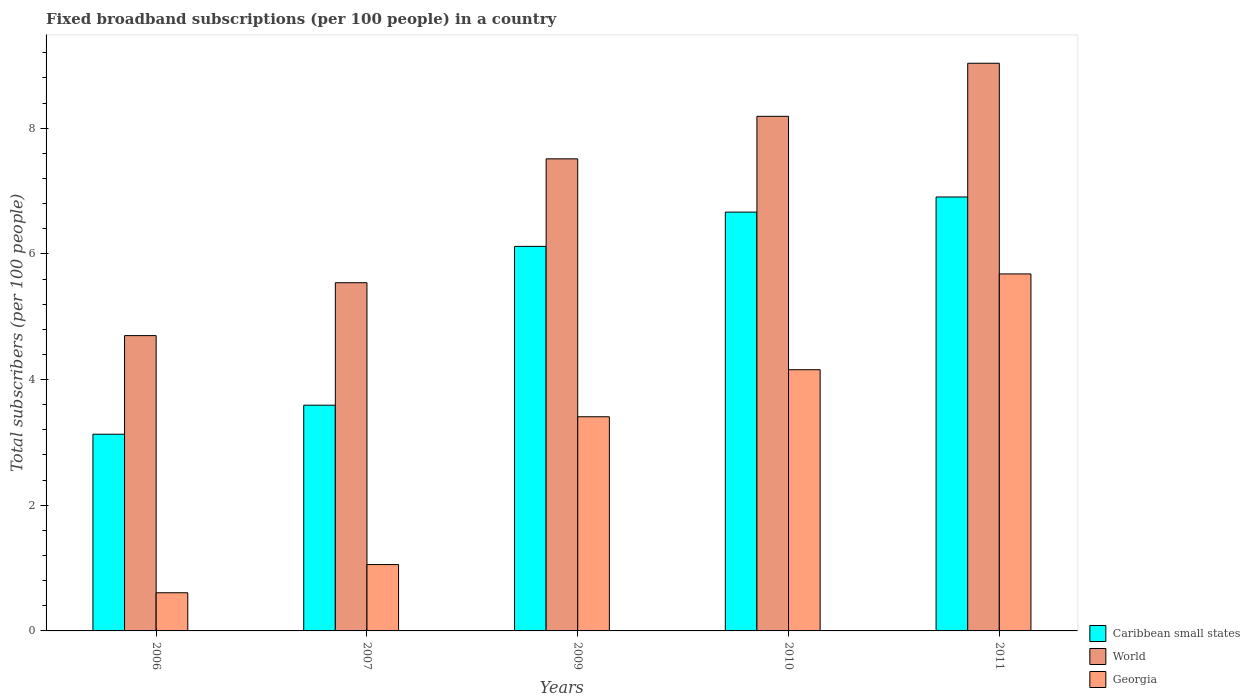How many groups of bars are there?
Your answer should be very brief. 5. Are the number of bars on each tick of the X-axis equal?
Offer a terse response. Yes. How many bars are there on the 3rd tick from the left?
Ensure brevity in your answer.  3. How many bars are there on the 3rd tick from the right?
Ensure brevity in your answer.  3. What is the number of broadband subscriptions in Caribbean small states in 2006?
Provide a succinct answer. 3.13. Across all years, what is the maximum number of broadband subscriptions in World?
Offer a terse response. 9.03. Across all years, what is the minimum number of broadband subscriptions in Caribbean small states?
Offer a terse response. 3.13. What is the total number of broadband subscriptions in World in the graph?
Ensure brevity in your answer.  34.98. What is the difference between the number of broadband subscriptions in World in 2006 and that in 2007?
Offer a very short reply. -0.84. What is the difference between the number of broadband subscriptions in World in 2010 and the number of broadband subscriptions in Georgia in 2009?
Your response must be concise. 4.78. What is the average number of broadband subscriptions in World per year?
Provide a short and direct response. 7. In the year 2009, what is the difference between the number of broadband subscriptions in Georgia and number of broadband subscriptions in Caribbean small states?
Offer a terse response. -2.71. In how many years, is the number of broadband subscriptions in World greater than 2.8?
Offer a very short reply. 5. What is the ratio of the number of broadband subscriptions in Caribbean small states in 2010 to that in 2011?
Provide a succinct answer. 0.97. Is the difference between the number of broadband subscriptions in Georgia in 2007 and 2010 greater than the difference between the number of broadband subscriptions in Caribbean small states in 2007 and 2010?
Provide a short and direct response. No. What is the difference between the highest and the second highest number of broadband subscriptions in Georgia?
Your answer should be compact. 1.52. What is the difference between the highest and the lowest number of broadband subscriptions in Georgia?
Provide a succinct answer. 5.07. What does the 1st bar from the left in 2006 represents?
Give a very brief answer. Caribbean small states. What does the 3rd bar from the right in 2009 represents?
Your answer should be compact. Caribbean small states. How many bars are there?
Your answer should be very brief. 15. Are all the bars in the graph horizontal?
Ensure brevity in your answer.  No. How many years are there in the graph?
Keep it short and to the point. 5. What is the difference between two consecutive major ticks on the Y-axis?
Your response must be concise. 2. Are the values on the major ticks of Y-axis written in scientific E-notation?
Your response must be concise. No. Where does the legend appear in the graph?
Ensure brevity in your answer.  Bottom right. How many legend labels are there?
Your answer should be very brief. 3. How are the legend labels stacked?
Your answer should be compact. Vertical. What is the title of the graph?
Your answer should be compact. Fixed broadband subscriptions (per 100 people) in a country. Does "Kazakhstan" appear as one of the legend labels in the graph?
Your response must be concise. No. What is the label or title of the Y-axis?
Your answer should be compact. Total subscribers (per 100 people). What is the Total subscribers (per 100 people) in Caribbean small states in 2006?
Make the answer very short. 3.13. What is the Total subscribers (per 100 people) in World in 2006?
Your answer should be very brief. 4.7. What is the Total subscribers (per 100 people) of Georgia in 2006?
Give a very brief answer. 0.61. What is the Total subscribers (per 100 people) in Caribbean small states in 2007?
Provide a short and direct response. 3.59. What is the Total subscribers (per 100 people) in World in 2007?
Your answer should be compact. 5.54. What is the Total subscribers (per 100 people) of Georgia in 2007?
Offer a very short reply. 1.06. What is the Total subscribers (per 100 people) in Caribbean small states in 2009?
Your response must be concise. 6.12. What is the Total subscribers (per 100 people) in World in 2009?
Ensure brevity in your answer.  7.51. What is the Total subscribers (per 100 people) in Georgia in 2009?
Make the answer very short. 3.41. What is the Total subscribers (per 100 people) of Caribbean small states in 2010?
Offer a very short reply. 6.66. What is the Total subscribers (per 100 people) of World in 2010?
Your response must be concise. 8.19. What is the Total subscribers (per 100 people) of Georgia in 2010?
Ensure brevity in your answer.  4.16. What is the Total subscribers (per 100 people) of Caribbean small states in 2011?
Your answer should be compact. 6.91. What is the Total subscribers (per 100 people) of World in 2011?
Provide a short and direct response. 9.03. What is the Total subscribers (per 100 people) of Georgia in 2011?
Your response must be concise. 5.68. Across all years, what is the maximum Total subscribers (per 100 people) of Caribbean small states?
Provide a short and direct response. 6.91. Across all years, what is the maximum Total subscribers (per 100 people) in World?
Keep it short and to the point. 9.03. Across all years, what is the maximum Total subscribers (per 100 people) in Georgia?
Your answer should be very brief. 5.68. Across all years, what is the minimum Total subscribers (per 100 people) in Caribbean small states?
Provide a short and direct response. 3.13. Across all years, what is the minimum Total subscribers (per 100 people) of World?
Keep it short and to the point. 4.7. Across all years, what is the minimum Total subscribers (per 100 people) in Georgia?
Offer a very short reply. 0.61. What is the total Total subscribers (per 100 people) of Caribbean small states in the graph?
Your answer should be compact. 26.41. What is the total Total subscribers (per 100 people) of World in the graph?
Your answer should be very brief. 34.98. What is the total Total subscribers (per 100 people) in Georgia in the graph?
Offer a very short reply. 14.91. What is the difference between the Total subscribers (per 100 people) in Caribbean small states in 2006 and that in 2007?
Your answer should be very brief. -0.46. What is the difference between the Total subscribers (per 100 people) in World in 2006 and that in 2007?
Provide a short and direct response. -0.84. What is the difference between the Total subscribers (per 100 people) in Georgia in 2006 and that in 2007?
Your answer should be compact. -0.45. What is the difference between the Total subscribers (per 100 people) of Caribbean small states in 2006 and that in 2009?
Provide a succinct answer. -2.99. What is the difference between the Total subscribers (per 100 people) in World in 2006 and that in 2009?
Provide a short and direct response. -2.81. What is the difference between the Total subscribers (per 100 people) in Georgia in 2006 and that in 2009?
Your answer should be very brief. -2.8. What is the difference between the Total subscribers (per 100 people) of Caribbean small states in 2006 and that in 2010?
Provide a short and direct response. -3.53. What is the difference between the Total subscribers (per 100 people) in World in 2006 and that in 2010?
Your answer should be very brief. -3.49. What is the difference between the Total subscribers (per 100 people) in Georgia in 2006 and that in 2010?
Ensure brevity in your answer.  -3.55. What is the difference between the Total subscribers (per 100 people) of Caribbean small states in 2006 and that in 2011?
Make the answer very short. -3.78. What is the difference between the Total subscribers (per 100 people) of World in 2006 and that in 2011?
Your response must be concise. -4.33. What is the difference between the Total subscribers (per 100 people) in Georgia in 2006 and that in 2011?
Provide a succinct answer. -5.07. What is the difference between the Total subscribers (per 100 people) of Caribbean small states in 2007 and that in 2009?
Make the answer very short. -2.53. What is the difference between the Total subscribers (per 100 people) in World in 2007 and that in 2009?
Keep it short and to the point. -1.97. What is the difference between the Total subscribers (per 100 people) in Georgia in 2007 and that in 2009?
Your answer should be compact. -2.35. What is the difference between the Total subscribers (per 100 people) of Caribbean small states in 2007 and that in 2010?
Offer a terse response. -3.07. What is the difference between the Total subscribers (per 100 people) in World in 2007 and that in 2010?
Provide a succinct answer. -2.65. What is the difference between the Total subscribers (per 100 people) of Georgia in 2007 and that in 2010?
Keep it short and to the point. -3.1. What is the difference between the Total subscribers (per 100 people) of Caribbean small states in 2007 and that in 2011?
Your answer should be compact. -3.31. What is the difference between the Total subscribers (per 100 people) of World in 2007 and that in 2011?
Provide a succinct answer. -3.49. What is the difference between the Total subscribers (per 100 people) in Georgia in 2007 and that in 2011?
Your response must be concise. -4.63. What is the difference between the Total subscribers (per 100 people) in Caribbean small states in 2009 and that in 2010?
Your response must be concise. -0.55. What is the difference between the Total subscribers (per 100 people) of World in 2009 and that in 2010?
Provide a short and direct response. -0.68. What is the difference between the Total subscribers (per 100 people) of Georgia in 2009 and that in 2010?
Provide a short and direct response. -0.75. What is the difference between the Total subscribers (per 100 people) in Caribbean small states in 2009 and that in 2011?
Keep it short and to the point. -0.79. What is the difference between the Total subscribers (per 100 people) in World in 2009 and that in 2011?
Keep it short and to the point. -1.52. What is the difference between the Total subscribers (per 100 people) in Georgia in 2009 and that in 2011?
Offer a terse response. -2.27. What is the difference between the Total subscribers (per 100 people) of Caribbean small states in 2010 and that in 2011?
Provide a short and direct response. -0.24. What is the difference between the Total subscribers (per 100 people) in World in 2010 and that in 2011?
Give a very brief answer. -0.84. What is the difference between the Total subscribers (per 100 people) of Georgia in 2010 and that in 2011?
Offer a terse response. -1.52. What is the difference between the Total subscribers (per 100 people) in Caribbean small states in 2006 and the Total subscribers (per 100 people) in World in 2007?
Offer a terse response. -2.41. What is the difference between the Total subscribers (per 100 people) in Caribbean small states in 2006 and the Total subscribers (per 100 people) in Georgia in 2007?
Offer a terse response. 2.07. What is the difference between the Total subscribers (per 100 people) of World in 2006 and the Total subscribers (per 100 people) of Georgia in 2007?
Your answer should be compact. 3.64. What is the difference between the Total subscribers (per 100 people) in Caribbean small states in 2006 and the Total subscribers (per 100 people) in World in 2009?
Provide a succinct answer. -4.38. What is the difference between the Total subscribers (per 100 people) of Caribbean small states in 2006 and the Total subscribers (per 100 people) of Georgia in 2009?
Offer a very short reply. -0.28. What is the difference between the Total subscribers (per 100 people) of World in 2006 and the Total subscribers (per 100 people) of Georgia in 2009?
Provide a short and direct response. 1.29. What is the difference between the Total subscribers (per 100 people) in Caribbean small states in 2006 and the Total subscribers (per 100 people) in World in 2010?
Your response must be concise. -5.06. What is the difference between the Total subscribers (per 100 people) of Caribbean small states in 2006 and the Total subscribers (per 100 people) of Georgia in 2010?
Your answer should be very brief. -1.03. What is the difference between the Total subscribers (per 100 people) of World in 2006 and the Total subscribers (per 100 people) of Georgia in 2010?
Ensure brevity in your answer.  0.54. What is the difference between the Total subscribers (per 100 people) of Caribbean small states in 2006 and the Total subscribers (per 100 people) of World in 2011?
Make the answer very short. -5.9. What is the difference between the Total subscribers (per 100 people) of Caribbean small states in 2006 and the Total subscribers (per 100 people) of Georgia in 2011?
Your response must be concise. -2.55. What is the difference between the Total subscribers (per 100 people) of World in 2006 and the Total subscribers (per 100 people) of Georgia in 2011?
Give a very brief answer. -0.98. What is the difference between the Total subscribers (per 100 people) in Caribbean small states in 2007 and the Total subscribers (per 100 people) in World in 2009?
Ensure brevity in your answer.  -3.92. What is the difference between the Total subscribers (per 100 people) in Caribbean small states in 2007 and the Total subscribers (per 100 people) in Georgia in 2009?
Your response must be concise. 0.18. What is the difference between the Total subscribers (per 100 people) of World in 2007 and the Total subscribers (per 100 people) of Georgia in 2009?
Give a very brief answer. 2.13. What is the difference between the Total subscribers (per 100 people) of Caribbean small states in 2007 and the Total subscribers (per 100 people) of World in 2010?
Provide a short and direct response. -4.6. What is the difference between the Total subscribers (per 100 people) in Caribbean small states in 2007 and the Total subscribers (per 100 people) in Georgia in 2010?
Make the answer very short. -0.56. What is the difference between the Total subscribers (per 100 people) in World in 2007 and the Total subscribers (per 100 people) in Georgia in 2010?
Offer a very short reply. 1.38. What is the difference between the Total subscribers (per 100 people) of Caribbean small states in 2007 and the Total subscribers (per 100 people) of World in 2011?
Keep it short and to the point. -5.44. What is the difference between the Total subscribers (per 100 people) of Caribbean small states in 2007 and the Total subscribers (per 100 people) of Georgia in 2011?
Your answer should be compact. -2.09. What is the difference between the Total subscribers (per 100 people) of World in 2007 and the Total subscribers (per 100 people) of Georgia in 2011?
Offer a terse response. -0.14. What is the difference between the Total subscribers (per 100 people) of Caribbean small states in 2009 and the Total subscribers (per 100 people) of World in 2010?
Give a very brief answer. -2.07. What is the difference between the Total subscribers (per 100 people) in Caribbean small states in 2009 and the Total subscribers (per 100 people) in Georgia in 2010?
Your answer should be compact. 1.96. What is the difference between the Total subscribers (per 100 people) of World in 2009 and the Total subscribers (per 100 people) of Georgia in 2010?
Your answer should be very brief. 3.36. What is the difference between the Total subscribers (per 100 people) in Caribbean small states in 2009 and the Total subscribers (per 100 people) in World in 2011?
Provide a succinct answer. -2.91. What is the difference between the Total subscribers (per 100 people) of Caribbean small states in 2009 and the Total subscribers (per 100 people) of Georgia in 2011?
Keep it short and to the point. 0.44. What is the difference between the Total subscribers (per 100 people) in World in 2009 and the Total subscribers (per 100 people) in Georgia in 2011?
Make the answer very short. 1.83. What is the difference between the Total subscribers (per 100 people) of Caribbean small states in 2010 and the Total subscribers (per 100 people) of World in 2011?
Your answer should be very brief. -2.37. What is the difference between the Total subscribers (per 100 people) in Caribbean small states in 2010 and the Total subscribers (per 100 people) in Georgia in 2011?
Your answer should be compact. 0.98. What is the difference between the Total subscribers (per 100 people) of World in 2010 and the Total subscribers (per 100 people) of Georgia in 2011?
Provide a short and direct response. 2.51. What is the average Total subscribers (per 100 people) in Caribbean small states per year?
Offer a very short reply. 5.28. What is the average Total subscribers (per 100 people) of World per year?
Ensure brevity in your answer.  7. What is the average Total subscribers (per 100 people) in Georgia per year?
Make the answer very short. 2.98. In the year 2006, what is the difference between the Total subscribers (per 100 people) in Caribbean small states and Total subscribers (per 100 people) in World?
Keep it short and to the point. -1.57. In the year 2006, what is the difference between the Total subscribers (per 100 people) in Caribbean small states and Total subscribers (per 100 people) in Georgia?
Provide a short and direct response. 2.52. In the year 2006, what is the difference between the Total subscribers (per 100 people) in World and Total subscribers (per 100 people) in Georgia?
Offer a very short reply. 4.09. In the year 2007, what is the difference between the Total subscribers (per 100 people) of Caribbean small states and Total subscribers (per 100 people) of World?
Offer a terse response. -1.95. In the year 2007, what is the difference between the Total subscribers (per 100 people) in Caribbean small states and Total subscribers (per 100 people) in Georgia?
Ensure brevity in your answer.  2.54. In the year 2007, what is the difference between the Total subscribers (per 100 people) of World and Total subscribers (per 100 people) of Georgia?
Keep it short and to the point. 4.49. In the year 2009, what is the difference between the Total subscribers (per 100 people) of Caribbean small states and Total subscribers (per 100 people) of World?
Offer a terse response. -1.39. In the year 2009, what is the difference between the Total subscribers (per 100 people) in Caribbean small states and Total subscribers (per 100 people) in Georgia?
Offer a very short reply. 2.71. In the year 2009, what is the difference between the Total subscribers (per 100 people) in World and Total subscribers (per 100 people) in Georgia?
Give a very brief answer. 4.1. In the year 2010, what is the difference between the Total subscribers (per 100 people) in Caribbean small states and Total subscribers (per 100 people) in World?
Offer a very short reply. -1.52. In the year 2010, what is the difference between the Total subscribers (per 100 people) of Caribbean small states and Total subscribers (per 100 people) of Georgia?
Your answer should be very brief. 2.51. In the year 2010, what is the difference between the Total subscribers (per 100 people) of World and Total subscribers (per 100 people) of Georgia?
Offer a terse response. 4.03. In the year 2011, what is the difference between the Total subscribers (per 100 people) in Caribbean small states and Total subscribers (per 100 people) in World?
Provide a succinct answer. -2.13. In the year 2011, what is the difference between the Total subscribers (per 100 people) of Caribbean small states and Total subscribers (per 100 people) of Georgia?
Ensure brevity in your answer.  1.22. In the year 2011, what is the difference between the Total subscribers (per 100 people) of World and Total subscribers (per 100 people) of Georgia?
Ensure brevity in your answer.  3.35. What is the ratio of the Total subscribers (per 100 people) of Caribbean small states in 2006 to that in 2007?
Your response must be concise. 0.87. What is the ratio of the Total subscribers (per 100 people) of World in 2006 to that in 2007?
Your answer should be very brief. 0.85. What is the ratio of the Total subscribers (per 100 people) of Georgia in 2006 to that in 2007?
Provide a succinct answer. 0.58. What is the ratio of the Total subscribers (per 100 people) in Caribbean small states in 2006 to that in 2009?
Keep it short and to the point. 0.51. What is the ratio of the Total subscribers (per 100 people) of World in 2006 to that in 2009?
Offer a very short reply. 0.63. What is the ratio of the Total subscribers (per 100 people) of Georgia in 2006 to that in 2009?
Provide a succinct answer. 0.18. What is the ratio of the Total subscribers (per 100 people) of Caribbean small states in 2006 to that in 2010?
Give a very brief answer. 0.47. What is the ratio of the Total subscribers (per 100 people) of World in 2006 to that in 2010?
Ensure brevity in your answer.  0.57. What is the ratio of the Total subscribers (per 100 people) of Georgia in 2006 to that in 2010?
Provide a succinct answer. 0.15. What is the ratio of the Total subscribers (per 100 people) in Caribbean small states in 2006 to that in 2011?
Your response must be concise. 0.45. What is the ratio of the Total subscribers (per 100 people) in World in 2006 to that in 2011?
Make the answer very short. 0.52. What is the ratio of the Total subscribers (per 100 people) of Georgia in 2006 to that in 2011?
Your response must be concise. 0.11. What is the ratio of the Total subscribers (per 100 people) of Caribbean small states in 2007 to that in 2009?
Keep it short and to the point. 0.59. What is the ratio of the Total subscribers (per 100 people) of World in 2007 to that in 2009?
Keep it short and to the point. 0.74. What is the ratio of the Total subscribers (per 100 people) of Georgia in 2007 to that in 2009?
Your response must be concise. 0.31. What is the ratio of the Total subscribers (per 100 people) in Caribbean small states in 2007 to that in 2010?
Make the answer very short. 0.54. What is the ratio of the Total subscribers (per 100 people) of World in 2007 to that in 2010?
Provide a short and direct response. 0.68. What is the ratio of the Total subscribers (per 100 people) of Georgia in 2007 to that in 2010?
Keep it short and to the point. 0.25. What is the ratio of the Total subscribers (per 100 people) in Caribbean small states in 2007 to that in 2011?
Make the answer very short. 0.52. What is the ratio of the Total subscribers (per 100 people) of World in 2007 to that in 2011?
Give a very brief answer. 0.61. What is the ratio of the Total subscribers (per 100 people) of Georgia in 2007 to that in 2011?
Provide a succinct answer. 0.19. What is the ratio of the Total subscribers (per 100 people) in Caribbean small states in 2009 to that in 2010?
Give a very brief answer. 0.92. What is the ratio of the Total subscribers (per 100 people) in World in 2009 to that in 2010?
Offer a terse response. 0.92. What is the ratio of the Total subscribers (per 100 people) in Georgia in 2009 to that in 2010?
Give a very brief answer. 0.82. What is the ratio of the Total subscribers (per 100 people) of Caribbean small states in 2009 to that in 2011?
Keep it short and to the point. 0.89. What is the ratio of the Total subscribers (per 100 people) in World in 2009 to that in 2011?
Provide a succinct answer. 0.83. What is the ratio of the Total subscribers (per 100 people) of Georgia in 2009 to that in 2011?
Provide a short and direct response. 0.6. What is the ratio of the Total subscribers (per 100 people) of Caribbean small states in 2010 to that in 2011?
Offer a terse response. 0.97. What is the ratio of the Total subscribers (per 100 people) in World in 2010 to that in 2011?
Your answer should be very brief. 0.91. What is the ratio of the Total subscribers (per 100 people) in Georgia in 2010 to that in 2011?
Provide a short and direct response. 0.73. What is the difference between the highest and the second highest Total subscribers (per 100 people) in Caribbean small states?
Keep it short and to the point. 0.24. What is the difference between the highest and the second highest Total subscribers (per 100 people) in World?
Provide a short and direct response. 0.84. What is the difference between the highest and the second highest Total subscribers (per 100 people) of Georgia?
Offer a very short reply. 1.52. What is the difference between the highest and the lowest Total subscribers (per 100 people) of Caribbean small states?
Ensure brevity in your answer.  3.78. What is the difference between the highest and the lowest Total subscribers (per 100 people) in World?
Your answer should be compact. 4.33. What is the difference between the highest and the lowest Total subscribers (per 100 people) of Georgia?
Give a very brief answer. 5.07. 